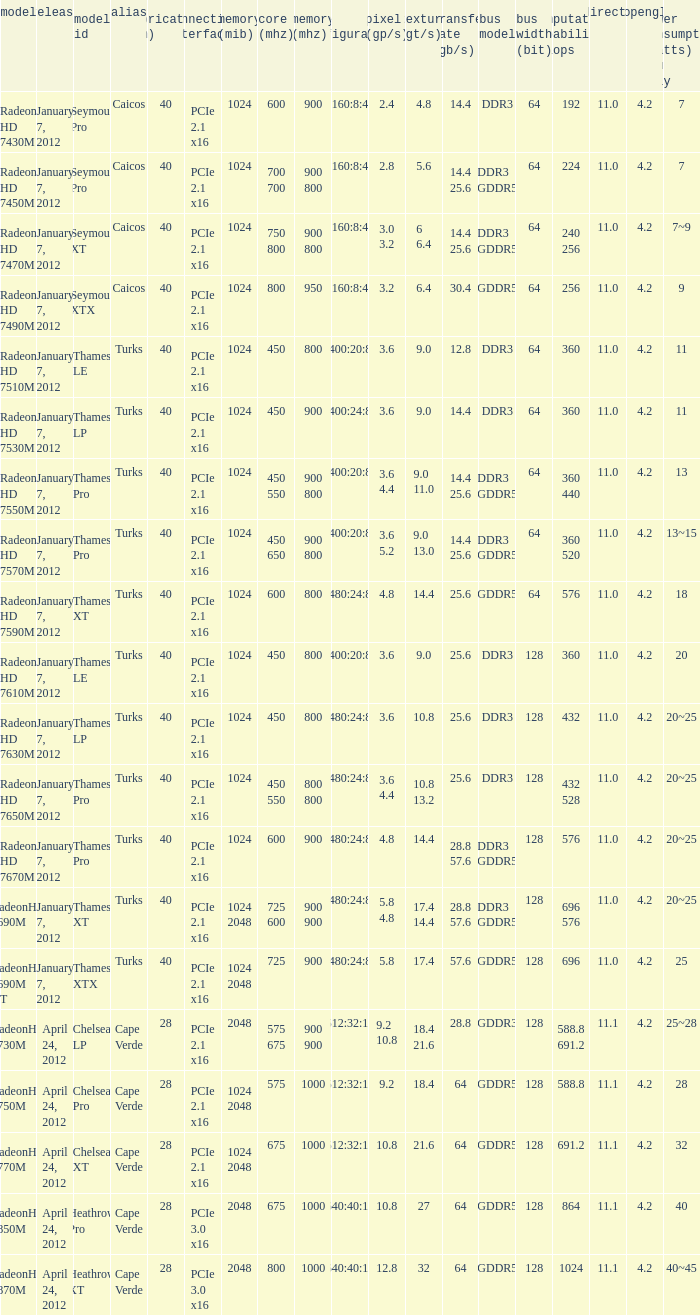What was the maximum fab (nm)? 40.0. 